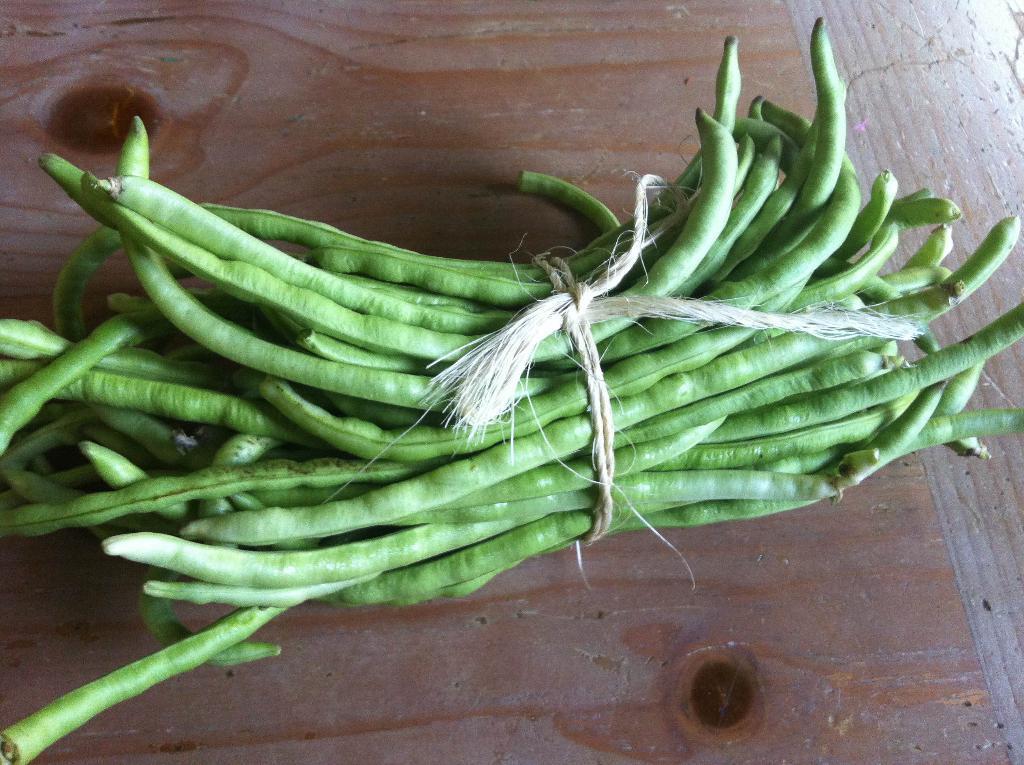Could you give a brief overview of what you see in this image? In the image we can see there are lot of beans which are tied together with a rope and kept on the table. 